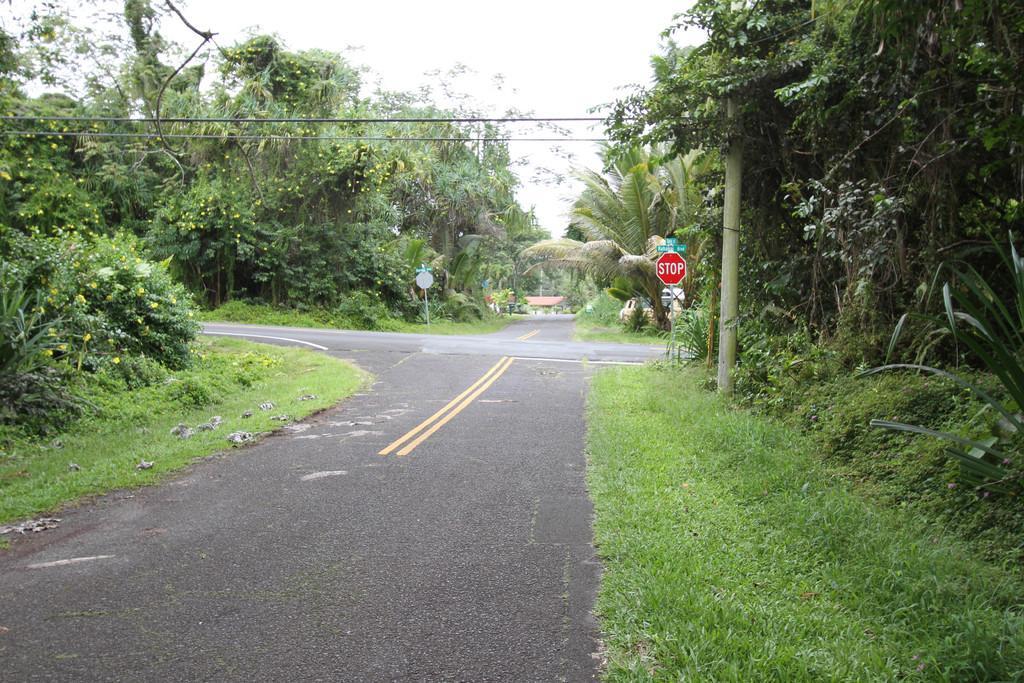Please provide a concise description of this image. In the picture we can see a cross road and on the four corners, we can see a grassy path with plants and trees and on the grass path we can see a pole with a stop board and in the background, we can see a house and on the top of it we can see some wires to the pole and sky. 